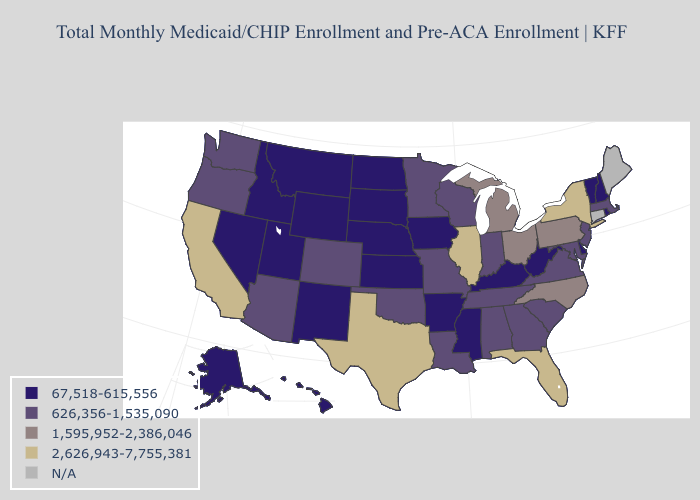What is the value of New Hampshire?
Write a very short answer. 67,518-615,556. Name the states that have a value in the range 2,626,943-7,755,381?
Concise answer only. California, Florida, Illinois, New York, Texas. Does New York have the highest value in the Northeast?
Answer briefly. Yes. Does the map have missing data?
Keep it brief. Yes. What is the value of Virginia?
Give a very brief answer. 626,356-1,535,090. What is the value of Maryland?
Give a very brief answer. 626,356-1,535,090. What is the value of North Dakota?
Be succinct. 67,518-615,556. Name the states that have a value in the range N/A?
Write a very short answer. Connecticut, Maine. What is the highest value in states that border New Jersey?
Write a very short answer. 2,626,943-7,755,381. Which states have the lowest value in the USA?
Concise answer only. Alaska, Arkansas, Delaware, Hawaii, Idaho, Iowa, Kansas, Kentucky, Mississippi, Montana, Nebraska, Nevada, New Hampshire, New Mexico, North Dakota, Rhode Island, South Dakota, Utah, Vermont, West Virginia, Wyoming. What is the value of Louisiana?
Give a very brief answer. 626,356-1,535,090. 